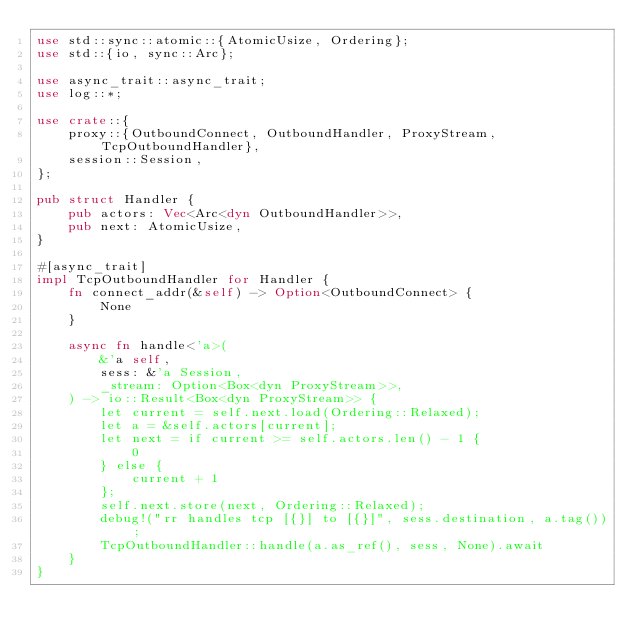Convert code to text. <code><loc_0><loc_0><loc_500><loc_500><_Rust_>use std::sync::atomic::{AtomicUsize, Ordering};
use std::{io, sync::Arc};

use async_trait::async_trait;
use log::*;

use crate::{
    proxy::{OutboundConnect, OutboundHandler, ProxyStream, TcpOutboundHandler},
    session::Session,
};

pub struct Handler {
    pub actors: Vec<Arc<dyn OutboundHandler>>,
    pub next: AtomicUsize,
}

#[async_trait]
impl TcpOutboundHandler for Handler {
    fn connect_addr(&self) -> Option<OutboundConnect> {
        None
    }

    async fn handle<'a>(
        &'a self,
        sess: &'a Session,
        _stream: Option<Box<dyn ProxyStream>>,
    ) -> io::Result<Box<dyn ProxyStream>> {
        let current = self.next.load(Ordering::Relaxed);
        let a = &self.actors[current];
        let next = if current >= self.actors.len() - 1 {
            0
        } else {
            current + 1
        };
        self.next.store(next, Ordering::Relaxed);
        debug!("rr handles tcp [{}] to [{}]", sess.destination, a.tag());
        TcpOutboundHandler::handle(a.as_ref(), sess, None).await
    }
}
</code> 